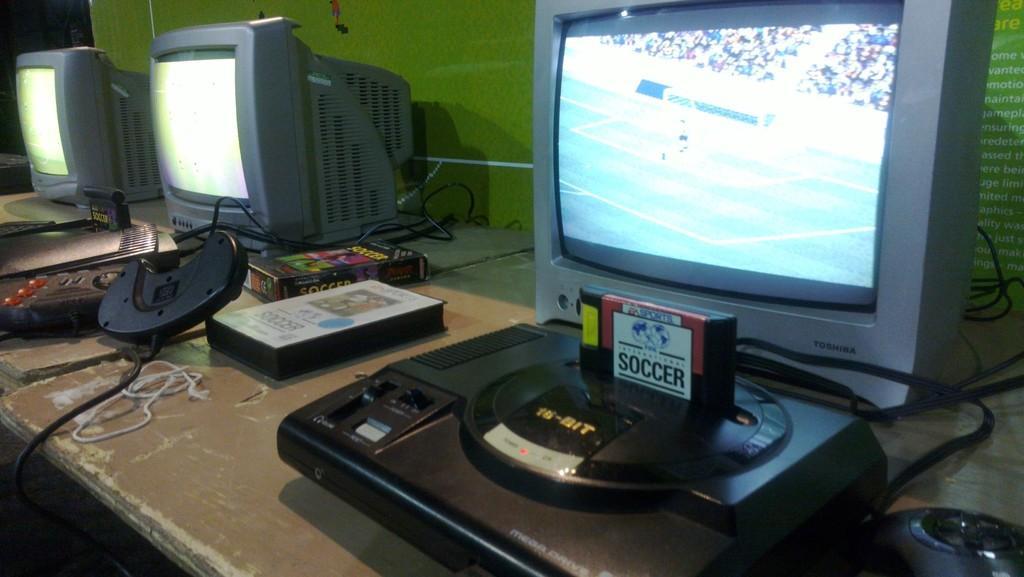Could you give a brief overview of what you see in this image? In this picture I can observe monitors on the tables. In the background there is a green color wall. 